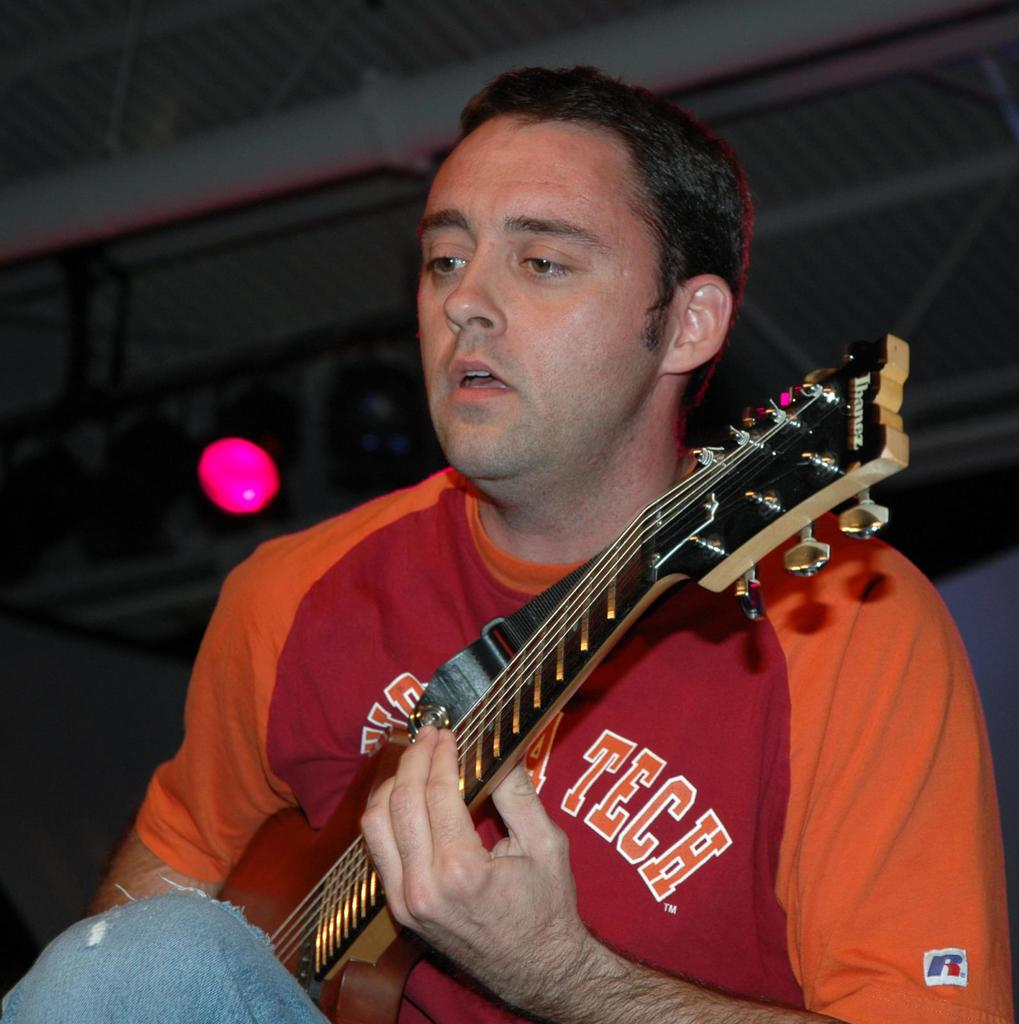What is the main subject of the image? There is a person in the image. What is the person wearing? The person is wearing an orange and red T-shirt. What activity is the person engaged in? The person is playing a guitar. What type of skin can be seen on the person's hands while playing the guitar? There is no specific detail about the person's skin visible in the image, as the focus is on the person's clothing and activity. 